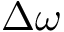<formula> <loc_0><loc_0><loc_500><loc_500>\Delta \omega</formula> 